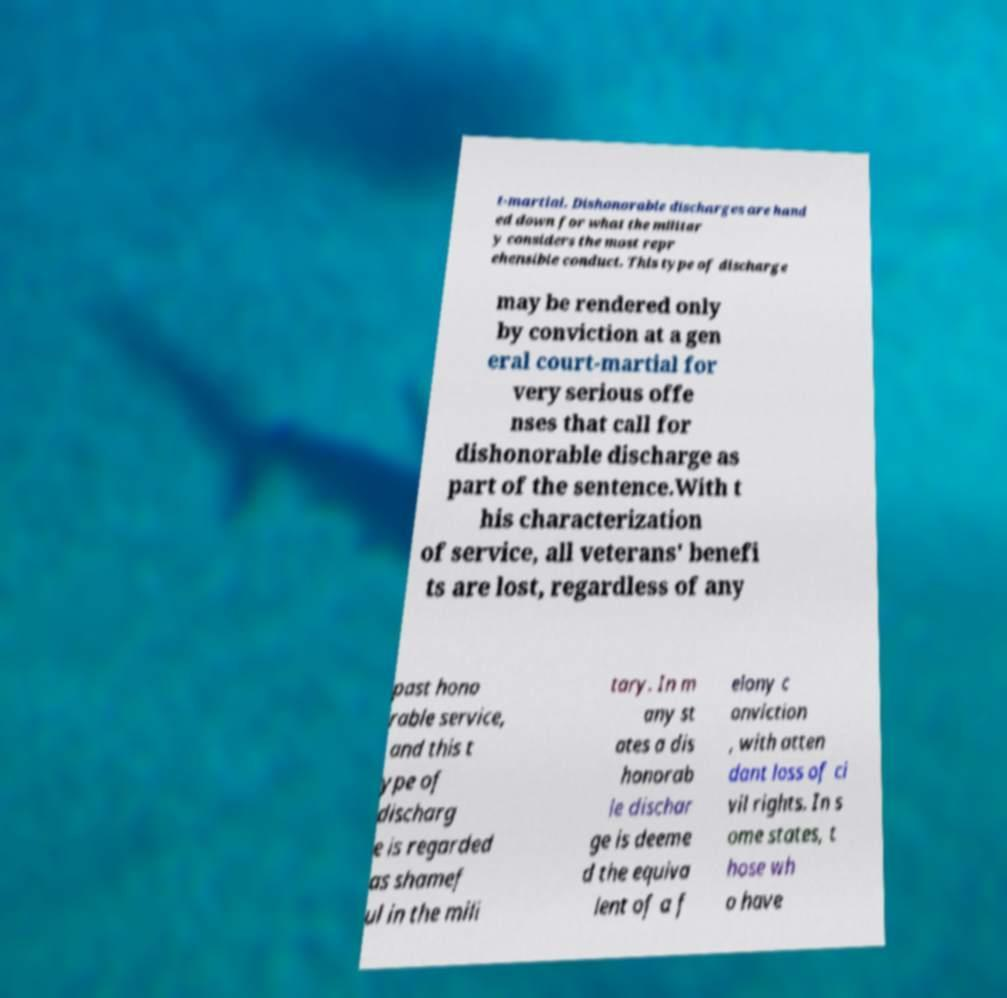Can you accurately transcribe the text from the provided image for me? t-martial. Dishonorable discharges are hand ed down for what the militar y considers the most repr ehensible conduct. This type of discharge may be rendered only by conviction at a gen eral court-martial for very serious offe nses that call for dishonorable discharge as part of the sentence.With t his characterization of service, all veterans' benefi ts are lost, regardless of any past hono rable service, and this t ype of discharg e is regarded as shamef ul in the mili tary. In m any st ates a dis honorab le dischar ge is deeme d the equiva lent of a f elony c onviction , with atten dant loss of ci vil rights. In s ome states, t hose wh o have 